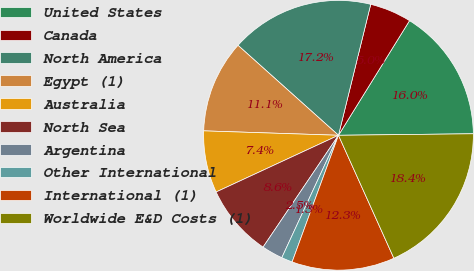Convert chart. <chart><loc_0><loc_0><loc_500><loc_500><pie_chart><fcel>United States<fcel>Canada<fcel>North America<fcel>Egypt (1)<fcel>Australia<fcel>North Sea<fcel>Argentina<fcel>Other International<fcel>International (1)<fcel>Worldwide E&D Costs (1)<nl><fcel>15.99%<fcel>4.99%<fcel>17.22%<fcel>11.1%<fcel>7.43%<fcel>8.65%<fcel>2.54%<fcel>1.32%<fcel>12.32%<fcel>18.44%<nl></chart> 